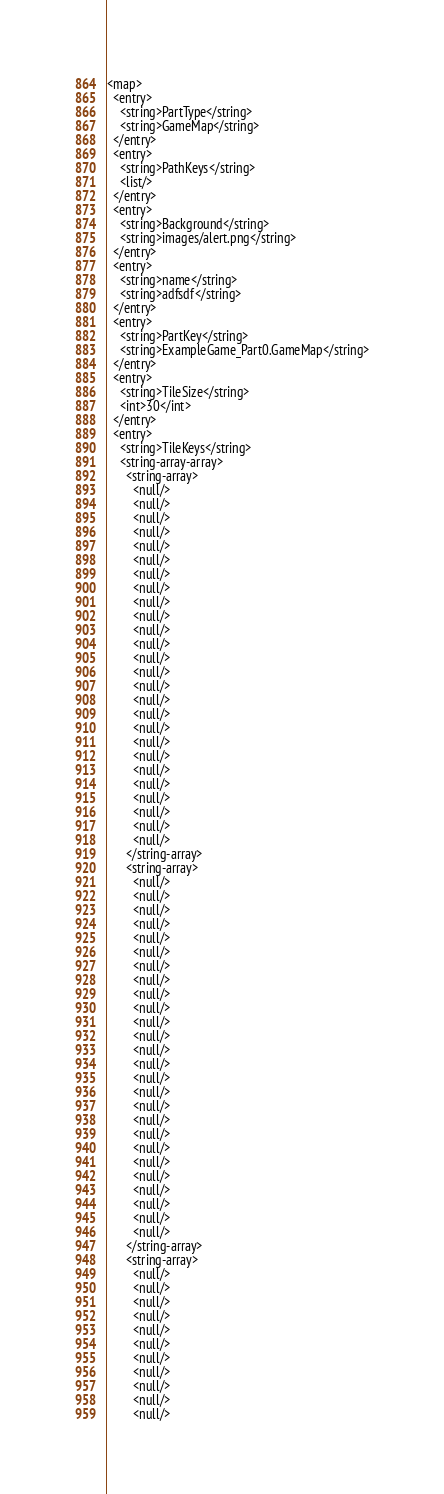Convert code to text. <code><loc_0><loc_0><loc_500><loc_500><_XML_><map>
  <entry>
    <string>PartType</string>
    <string>GameMap</string>
  </entry>
  <entry>
    <string>PathKeys</string>
    <list/>
  </entry>
  <entry>
    <string>Background</string>
    <string>images/alert.png</string>
  </entry>
  <entry>
    <string>name</string>
    <string>adfsdf</string>
  </entry>
  <entry>
    <string>PartKey</string>
    <string>ExampleGame_Part0.GameMap</string>
  </entry>
  <entry>
    <string>TileSize</string>
    <int>30</int>
  </entry>
  <entry>
    <string>TileKeys</string>
    <string-array-array>
      <string-array>
        <null/>
        <null/>
        <null/>
        <null/>
        <null/>
        <null/>
        <null/>
        <null/>
        <null/>
        <null/>
        <null/>
        <null/>
        <null/>
        <null/>
        <null/>
        <null/>
        <null/>
        <null/>
        <null/>
        <null/>
        <null/>
        <null/>
        <null/>
        <null/>
        <null/>
        <null/>
      </string-array>
      <string-array>
        <null/>
        <null/>
        <null/>
        <null/>
        <null/>
        <null/>
        <null/>
        <null/>
        <null/>
        <null/>
        <null/>
        <null/>
        <null/>
        <null/>
        <null/>
        <null/>
        <null/>
        <null/>
        <null/>
        <null/>
        <null/>
        <null/>
        <null/>
        <null/>
        <null/>
        <null/>
      </string-array>
      <string-array>
        <null/>
        <null/>
        <null/>
        <null/>
        <null/>
        <null/>
        <null/>
        <null/>
        <null/>
        <null/>
        <null/></code> 